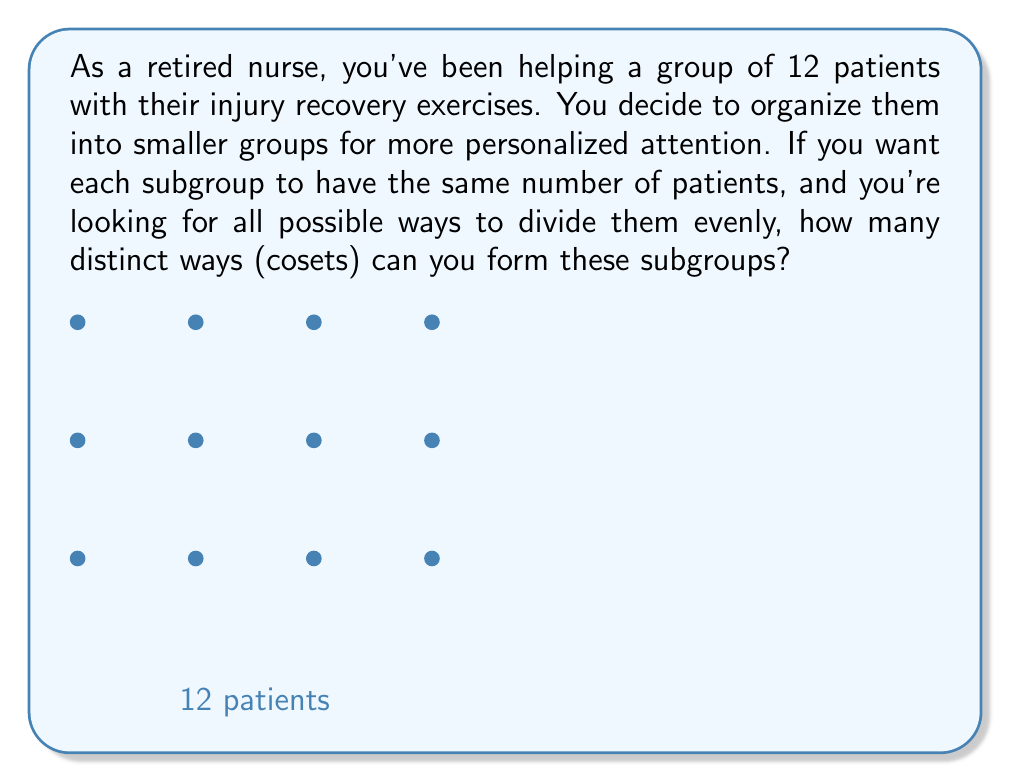Can you answer this question? Let's approach this step-by-step:

1) In group theory, the number of distinct cosets is equal to the index of a subgroup. In this case, we're looking for the number of ways to partition the group evenly.

2) The number of patients (12) represents the order of our group, let's call it $|G| = 12$.

3) The possible subgroup orders (sizes of smaller groups) are the divisors of 12:
   $1, 2, 3, 4, 6,$ and $12$

4) For each divisor $d$, the number of cosets would be $\frac{|G|}{d}$:

   For $d = 1$:  $\frac{12}{1} = 12$ cosets
   For $d = 2$:  $\frac{12}{2} = 6$ cosets
   For $d = 3$:  $\frac{12}{3} = 4$ cosets
   For $d = 4$:  $\frac{12}{4} = 3$ cosets
   For $d = 6$:  $\frac{12}{6} = 2$ cosets
   For $d = 12$: $\frac{12}{12} = 1$ coset

5) Each of these represents a distinct way to form subgroups, so we sum them:

   $12 + 6 + 4 + 3 + 2 + 1 = 28$

Therefore, there are 28 distinct ways (cosets) to form these subgroups.
Answer: 28 